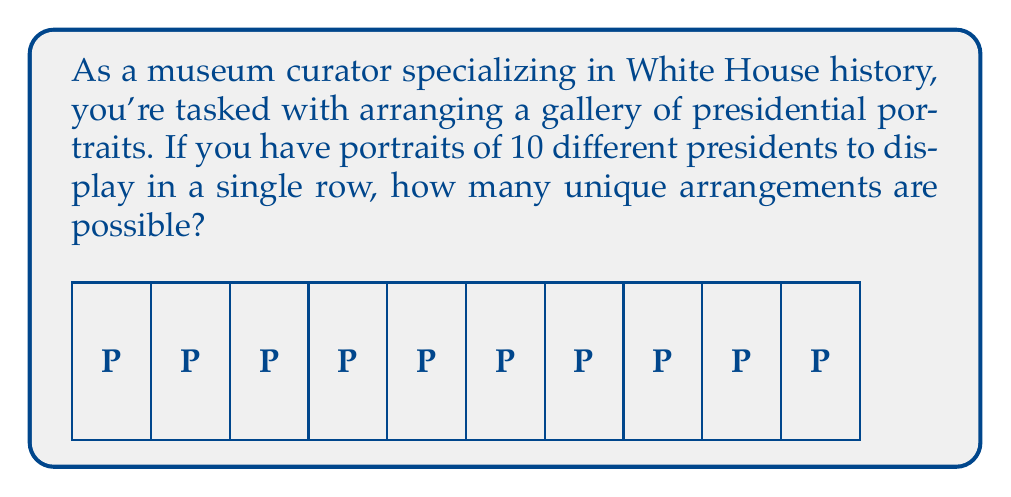Can you solve this math problem? To solve this problem, we need to understand the concept of permutations in abstract algebra.

1) This scenario represents a permutation without repetition, as each portrait is unique and used only once.

2) The number of permutations of n distinct objects is given by the factorial of n, denoted as n!

3) In this case, we have 10 distinct portraits, so n = 10

4) The formula for the number of permutations is:

   $$P(10) = 10!$$

5) Let's calculate 10!:
   $$10! = 10 \times 9 \times 8 \times 7 \times 6 \times 5 \times 4 \times 3 \times 2 \times 1$$

6) Multiplying these numbers:
   $$10! = 3,628,800$$

Therefore, there are 3,628,800 unique ways to arrange the 10 presidential portraits in a single row.
Answer: $3,628,800$ 